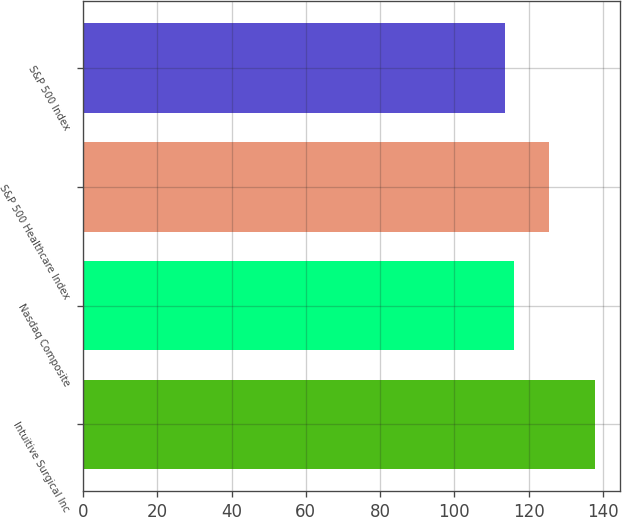<chart> <loc_0><loc_0><loc_500><loc_500><bar_chart><fcel>Intuitive Surgical Inc<fcel>Nasdaq Composite<fcel>S&P 500 Healthcare Index<fcel>S&P 500 Index<nl><fcel>137.72<fcel>116.09<fcel>125.34<fcel>113.69<nl></chart> 